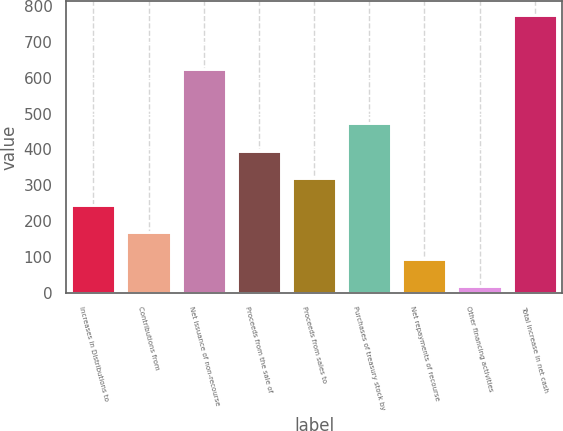<chart> <loc_0><loc_0><loc_500><loc_500><bar_chart><fcel>Increases in Distributions to<fcel>Contributions from<fcel>Net issuance of non-recourse<fcel>Proceeds from the sale of<fcel>Proceeds from sales to<fcel>Purchases of treasury stock by<fcel>Net repayments of recourse<fcel>Other financing activities<fcel>Total increase in net cash<nl><fcel>245.8<fcel>170.2<fcel>624<fcel>397<fcel>321.4<fcel>472.6<fcel>94.6<fcel>19<fcel>775<nl></chart> 